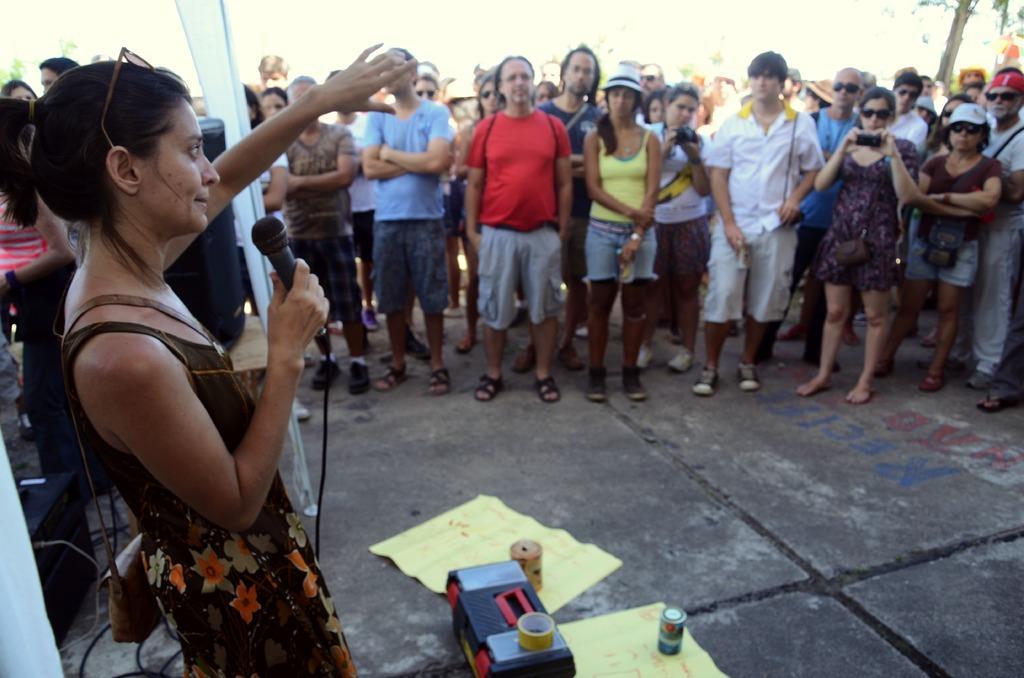Could you give a brief overview of what you see in this image? In this picture there are people, among them there is a woman standing and holding a microphone and carrying a bag and we can see clothes, devices, papers, tins and an object on the ground. In the background of the image it is blurry. 